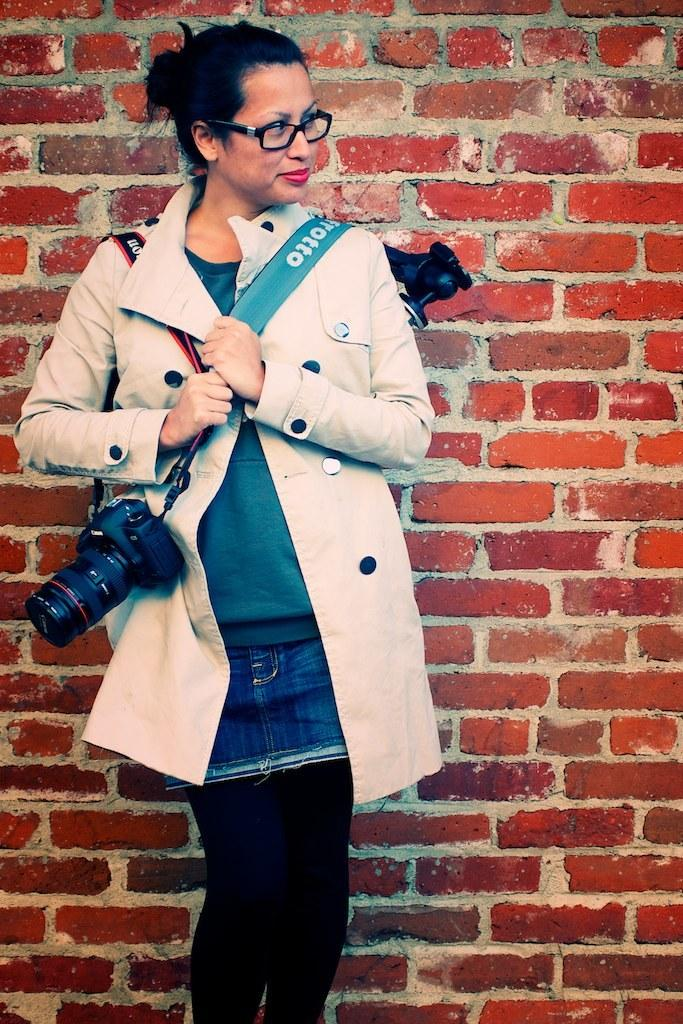Who is the main subject in the image? There is a woman in the image. What is the woman doing in the image? The woman is standing. What is the woman wearing in the image? The woman is wearing a jacket. What is the woman holding in the image? The woman is carrying a camera and some other objects. What can be seen in the background of the image? There is a brick wall in the background of the image. What type of leaf is the woman using to take team photos in the image? There is no leaf or team present in the image. The woman is carrying a camera, but there is no indication that she is taking team photos. 